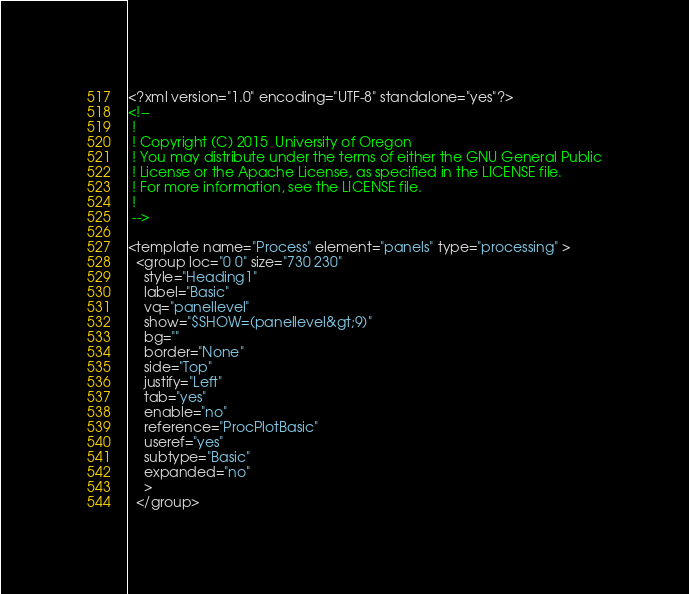Convert code to text. <code><loc_0><loc_0><loc_500><loc_500><_XML_><?xml version="1.0" encoding="UTF-8" standalone="yes"?>
<!--
 !
 ! Copyright (C) 2015  University of Oregon
 ! You may distribute under the terms of either the GNU General Public
 ! License or the Apache License, as specified in the LICENSE file.
 ! For more information, see the LICENSE file.
 !
 -->

<template name="Process" element="panels" type="processing" >
  <group loc="0 0" size="730 230"
    style="Heading1"
    label="Basic"
    vq="panellevel"
    show="$SHOW=(panellevel&gt;9)"
    bg=""
    border="None"
    side="Top"
    justify="Left"
    tab="yes"
    enable="no"
    reference="ProcPlotBasic"
    useref="yes"
    subtype="Basic"
    expanded="no"
    >
  </group></code> 